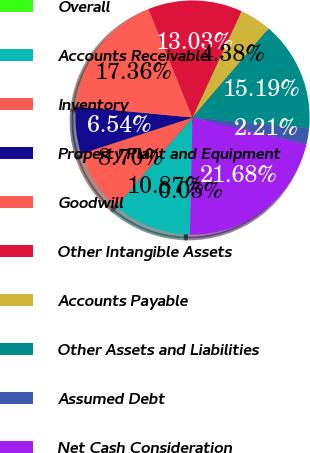Convert chart to OTSL. <chart><loc_0><loc_0><loc_500><loc_500><pie_chart><fcel>Overall<fcel>Accounts Receivable<fcel>Inventory<fcel>Property Plant and Equipment<fcel>Goodwill<fcel>Other Intangible Assets<fcel>Accounts Payable<fcel>Other Assets and Liabilities<fcel>Assumed Debt<fcel>Net Cash Consideration<nl><fcel>0.05%<fcel>10.87%<fcel>8.7%<fcel>6.54%<fcel>17.36%<fcel>13.03%<fcel>4.38%<fcel>15.19%<fcel>2.21%<fcel>21.68%<nl></chart> 